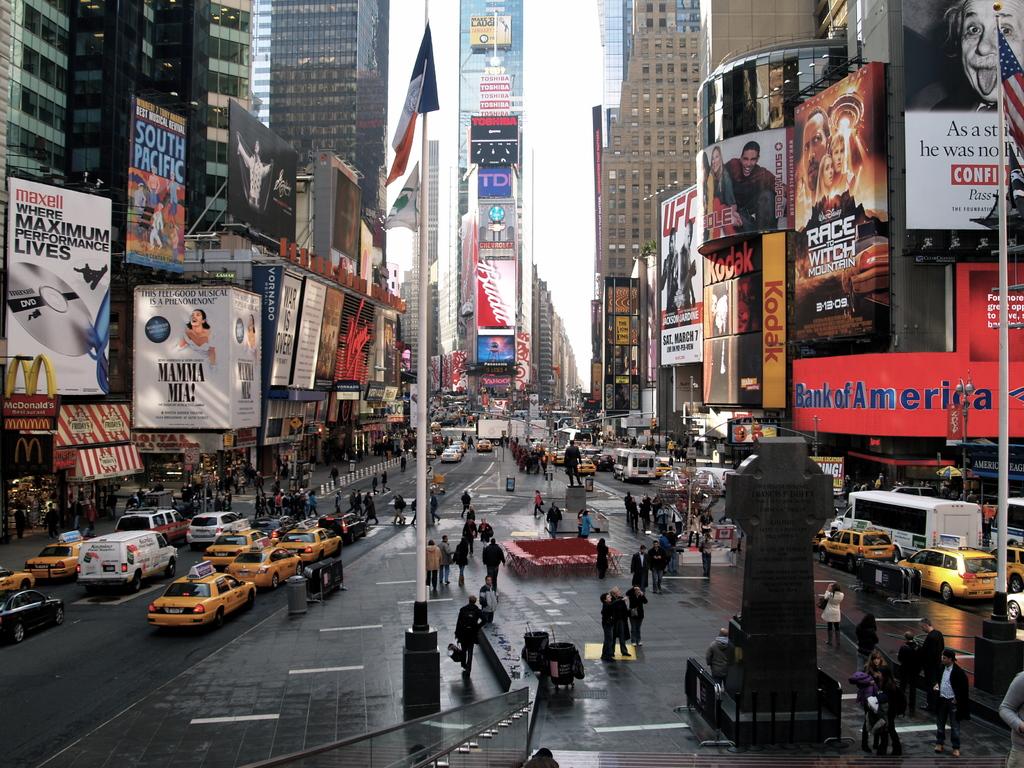What are the yellow cars?
Ensure brevity in your answer.  Answering does not require reading text in the image. 